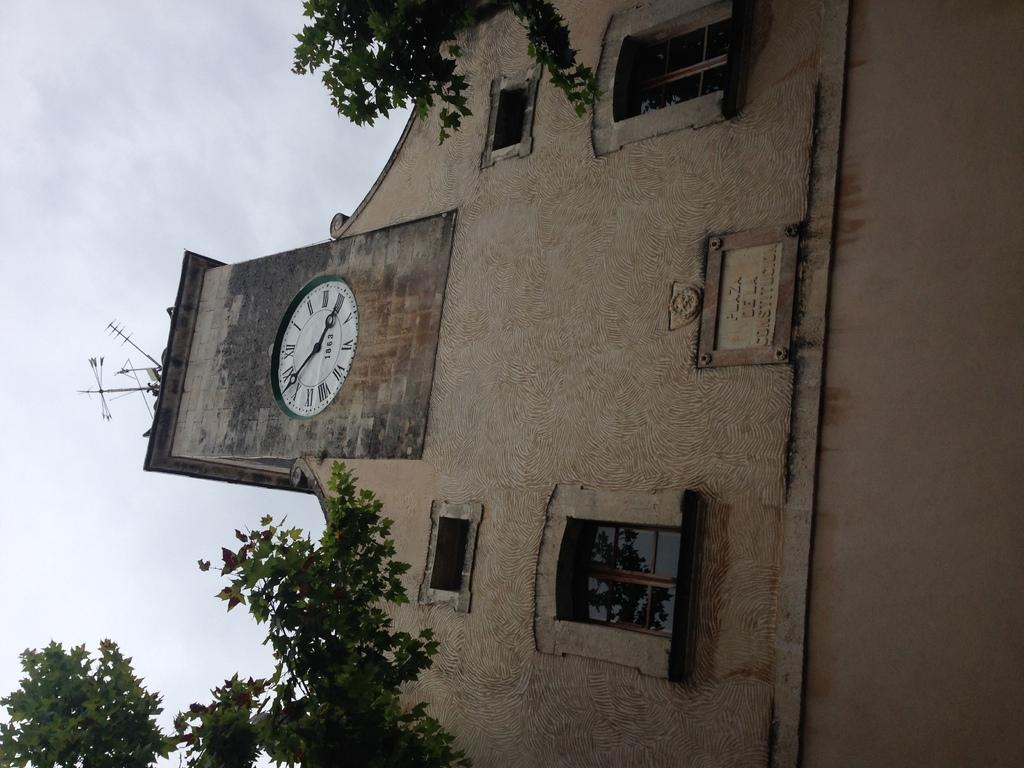<image>
Give a short and clear explanation of the subsequent image. The clock tower at Plaza Dela Constitucion shows 1863. 